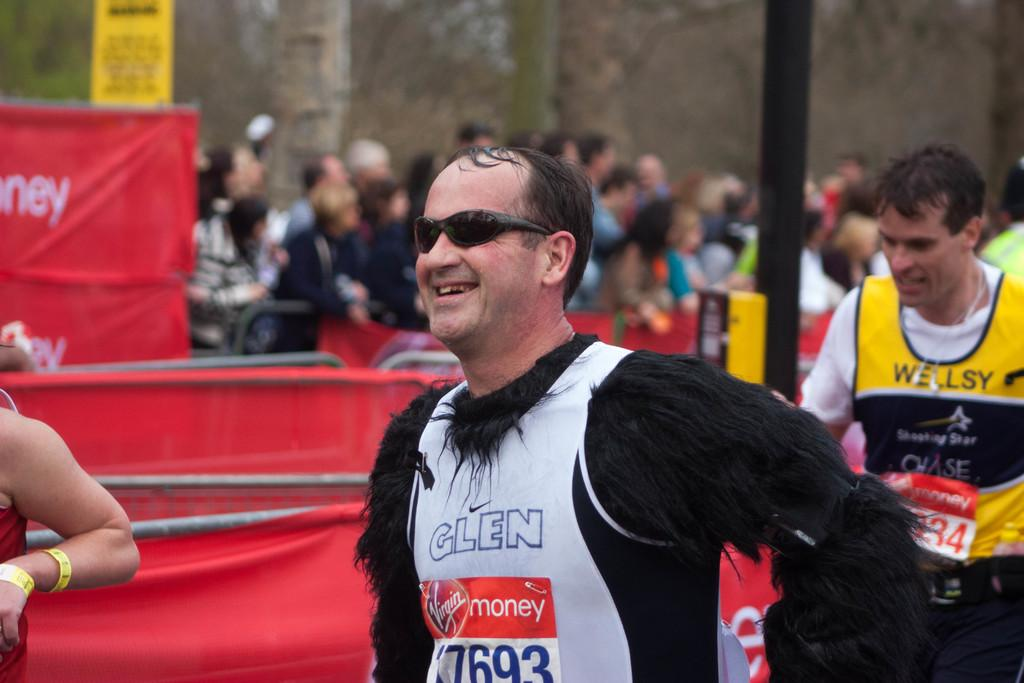What can be observed about the people in the image? There are people wearing different color dresses in the image. What can be seen in the background of the image? There are red cloths, poles, and signboards visible in the background. How would you describe the background of the image? The background is blurred. What type of magic trick is being performed with the curve in the image? There is no curve or magic trick present in the image. How many knots are visible on the people's dresses in the image? The provided facts do not mention any knots on the people's dresses, so we cannot determine the number of knots. 